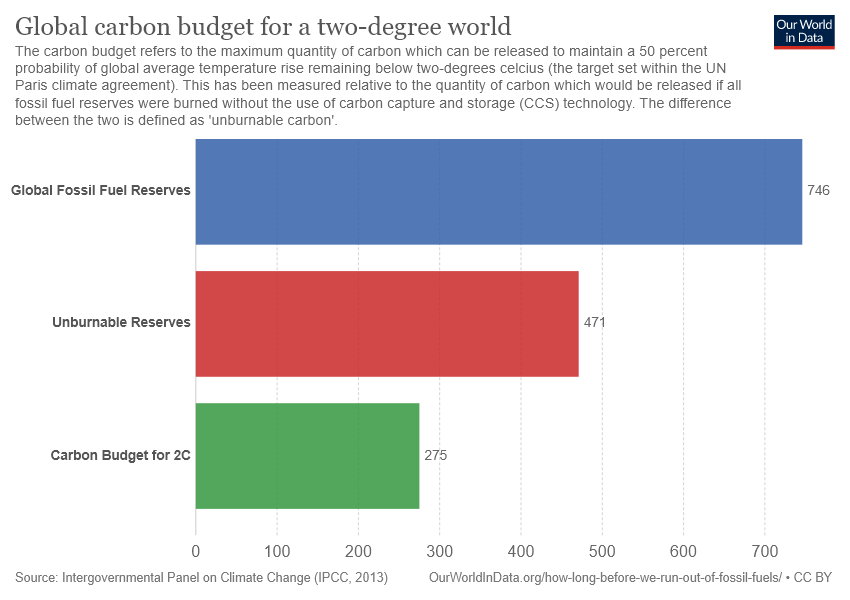Highlight a few significant elements in this photo. The term "Unburnable Reserves" represents the Red bar in the graphic. The difference between the smallest two bars is smaller than the difference between the largest two bars. 